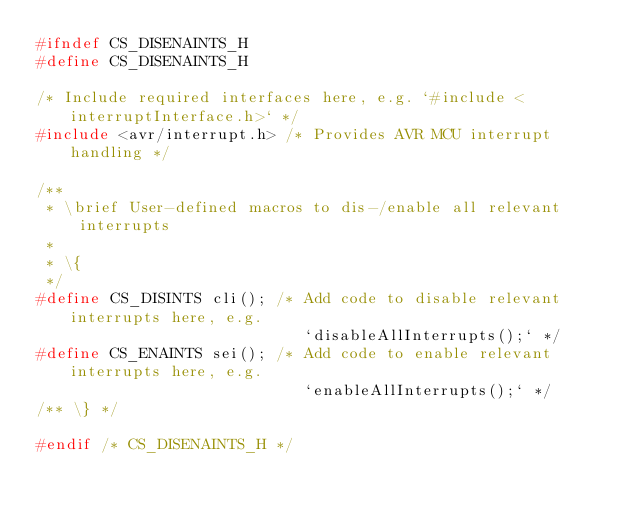Convert code to text. <code><loc_0><loc_0><loc_500><loc_500><_C_>#ifndef CS_DISENAINTS_H
#define CS_DISENAINTS_H

/* Include required interfaces here, e.g. `#include <interruptInterface.h>` */
#include <avr/interrupt.h> /* Provides AVR MCU interrupt handling */

/**
 * \brief User-defined macros to dis-/enable all relevant interrupts
 *
 * \{
 */
#define CS_DISINTS cli(); /* Add code to disable relevant interrupts here, e.g.
                             `disableAllInterrupts();` */
#define CS_ENAINTS sei(); /* Add code to enable relevant interrupts here, e.g.
                             `enableAllInterrupts();` */
/** \} */

#endif /* CS_DISENAINTS_H */
</code> 